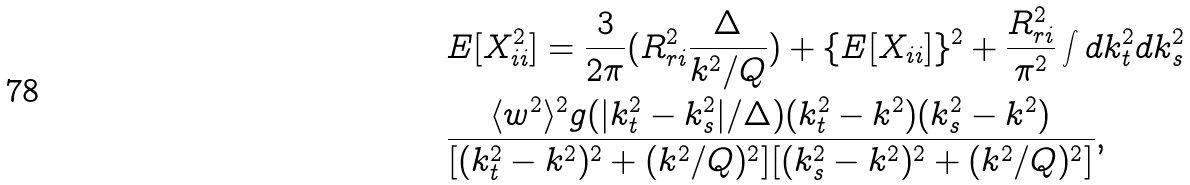Convert formula to latex. <formula><loc_0><loc_0><loc_500><loc_500>& E [ X _ { i i } ^ { 2 } ] = \frac { 3 } { 2 \pi } ( R _ { r i } ^ { 2 } \frac { \Delta } { k ^ { 2 } / Q } ) + \{ E [ X _ { i i } ] \} ^ { 2 } + \frac { R _ { r i } ^ { 2 } } { \pi ^ { 2 } } \int d k _ { t } ^ { 2 } d k _ { s } ^ { 2 } \\ & \frac { \langle w ^ { 2 } \rangle ^ { 2 } g ( | k _ { t } ^ { 2 } - k _ { s } ^ { 2 } | / \Delta ) ( k _ { t } ^ { 2 } - k ^ { 2 } ) ( k _ { s } ^ { 2 } - k ^ { 2 } ) } { [ ( k _ { t } ^ { 2 } - k ^ { 2 } ) ^ { 2 } + ( k ^ { 2 } / Q ) ^ { 2 } ] [ ( k _ { s } ^ { 2 } - k ^ { 2 } ) ^ { 2 } + ( k ^ { 2 } / Q ) ^ { 2 } ] } ,</formula> 